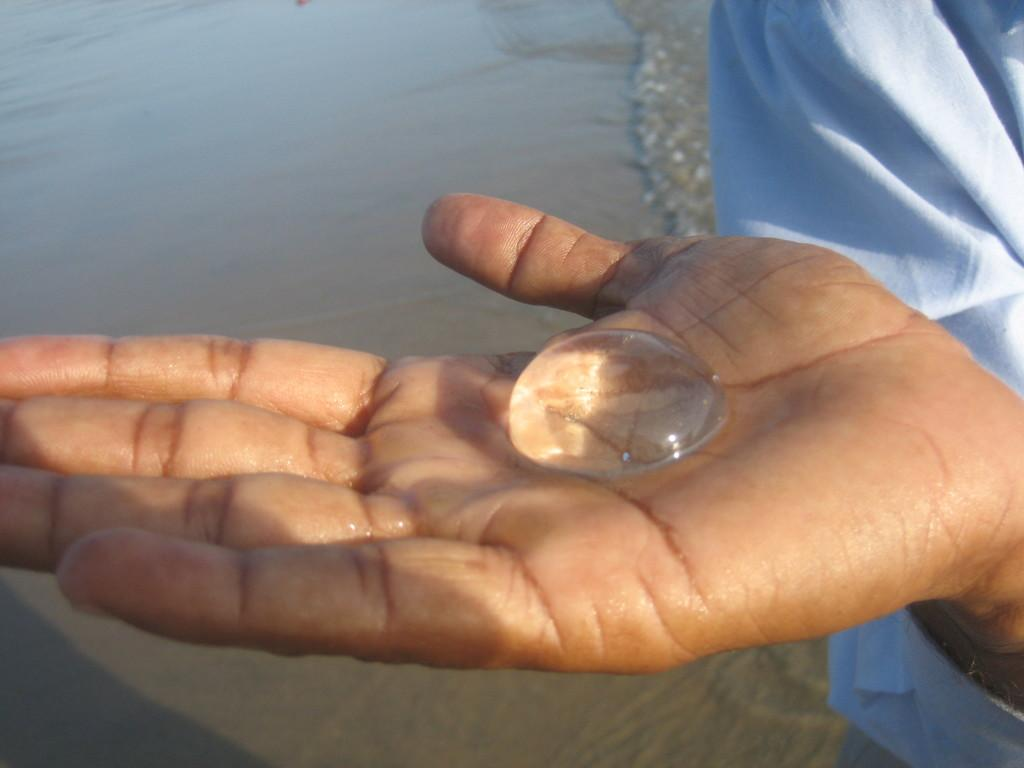What is present in the image? There is a person in the image. What is the person holding? The person is holding an object. What can be seen on the surface at the bottom of the image? There is water visible on the surface at the bottom of the image. What type of mitten is the person wearing in the image? There is no mitten present in the image. Can you see the person's veins through their skin in the image? The image does not provide enough detail to see the person's veins through their skin. 